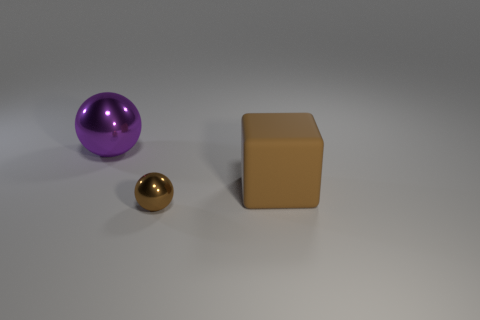Is there anything else that has the same size as the brown sphere?
Give a very brief answer. No. There is a ball that is behind the brown object right of the ball in front of the large metal ball; what size is it?
Give a very brief answer. Large. There is a purple object; does it have the same shape as the thing that is in front of the big brown object?
Offer a terse response. Yes. What size is the purple thing that is made of the same material as the tiny ball?
Give a very brief answer. Large. Is there any other thing that has the same color as the big shiny sphere?
Give a very brief answer. No. What material is the big thing that is on the right side of the large thing behind the large object right of the purple metallic sphere?
Your response must be concise. Rubber. What number of metallic objects are either brown spheres or purple spheres?
Give a very brief answer. 2. Do the cube and the large sphere have the same color?
Provide a succinct answer. No. Is there anything else that has the same material as the small brown ball?
Your response must be concise. Yes. What number of things are either large brown matte objects or shiny objects in front of the purple metal sphere?
Make the answer very short. 2. 